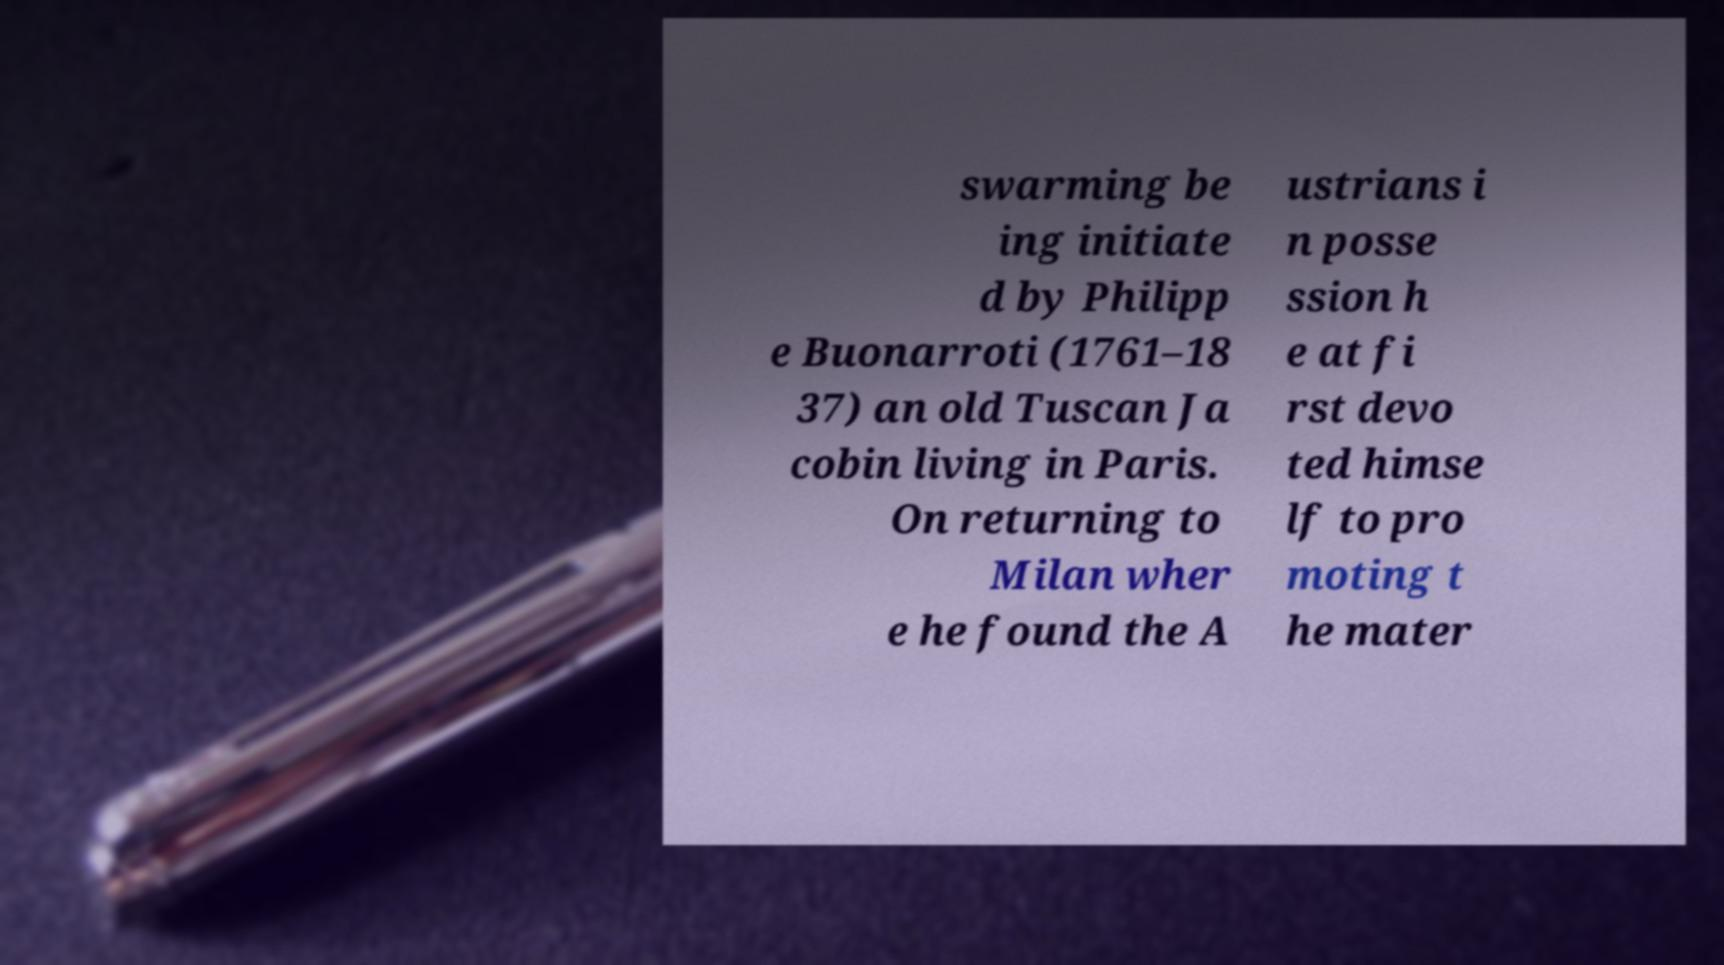I need the written content from this picture converted into text. Can you do that? swarming be ing initiate d by Philipp e Buonarroti (1761–18 37) an old Tuscan Ja cobin living in Paris. On returning to Milan wher e he found the A ustrians i n posse ssion h e at fi rst devo ted himse lf to pro moting t he mater 